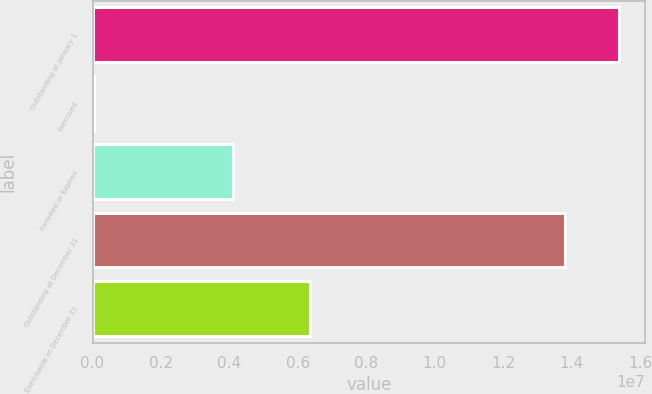Convert chart. <chart><loc_0><loc_0><loc_500><loc_500><bar_chart><fcel>Outstanding at January 1<fcel>Exercised<fcel>Forfeited or Expired<fcel>Outstanding at December 31<fcel>Exercisable at December 31<nl><fcel>1.53843e+07<fcel>38720<fcel>4.09203e+06<fcel>1.38098e+07<fcel>6.34182e+06<nl></chart> 